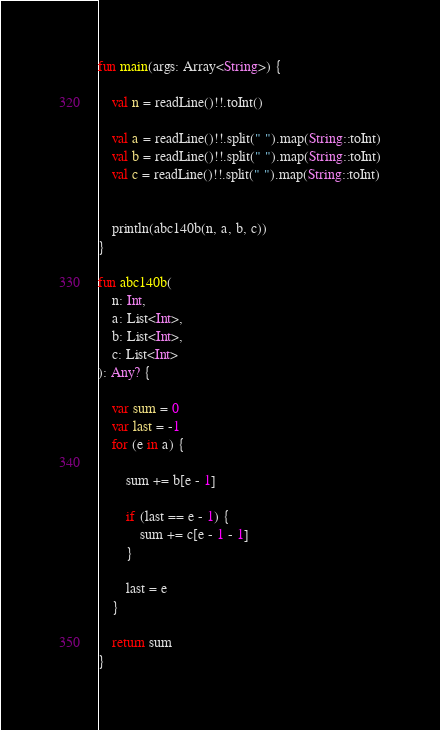<code> <loc_0><loc_0><loc_500><loc_500><_Kotlin_>fun main(args: Array<String>) {

    val n = readLine()!!.toInt()

    val a = readLine()!!.split(" ").map(String::toInt)
    val b = readLine()!!.split(" ").map(String::toInt)
    val c = readLine()!!.split(" ").map(String::toInt)


    println(abc140b(n, a, b, c))
}

fun abc140b(
    n: Int,
    a: List<Int>,
    b: List<Int>,
    c: List<Int>
): Any? {

    var sum = 0
    var last = -1
    for (e in a) {

        sum += b[e - 1]

        if (last == e - 1) {
            sum += c[e - 1 - 1]
        }

        last = e
    }

    return sum
}
</code> 